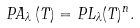Convert formula to latex. <formula><loc_0><loc_0><loc_500><loc_500>P A _ { \lambda } \left ( T \right ) = P L _ { \lambda } ( T ) ^ { n } .</formula> 